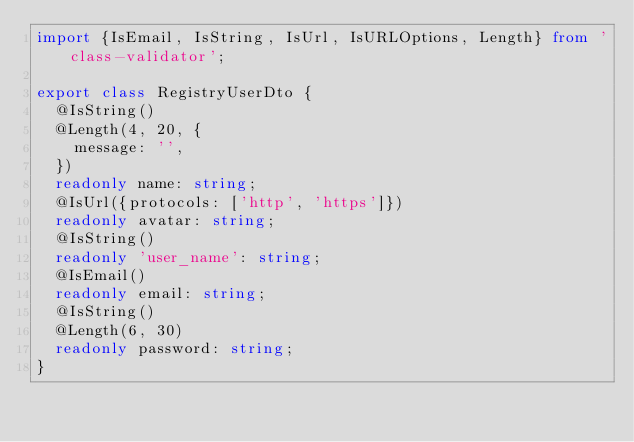<code> <loc_0><loc_0><loc_500><loc_500><_TypeScript_>import {IsEmail, IsString, IsUrl, IsURLOptions, Length} from 'class-validator';

export class RegistryUserDto {
  @IsString()
  @Length(4, 20, {
    message: '',
  })
  readonly name: string;
  @IsUrl({protocols: ['http', 'https']})
  readonly avatar: string;
  @IsString()
  readonly 'user_name': string;
  @IsEmail()
  readonly email: string;
  @IsString()
  @Length(6, 30)
  readonly password: string;
}
</code> 